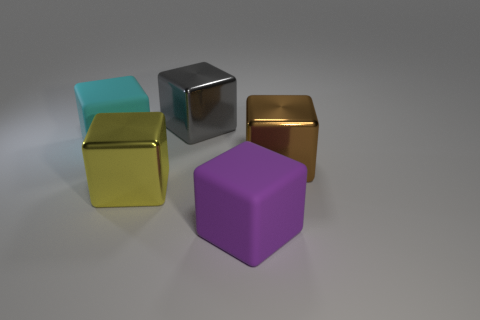Subtract all brown cubes. How many cubes are left? 4 Add 2 purple shiny cylinders. How many objects exist? 7 Subtract all yellow blocks. How many blocks are left? 4 Subtract 0 purple cylinders. How many objects are left? 5 Subtract 2 blocks. How many blocks are left? 3 Subtract all brown cubes. Subtract all yellow balls. How many cubes are left? 4 Subtract all red cylinders. Subtract all big rubber objects. How many objects are left? 3 Add 2 purple objects. How many purple objects are left? 3 Add 5 yellow cubes. How many yellow cubes exist? 6 